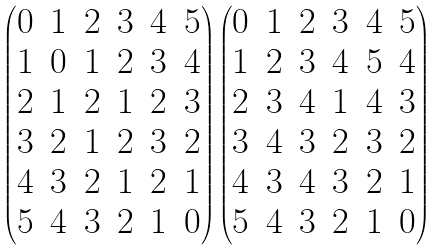<formula> <loc_0><loc_0><loc_500><loc_500>\begin{pmatrix} 0 & 1 & 2 & 3 & 4 & 5 \\ 1 & 0 & 1 & 2 & 3 & 4 \\ 2 & 1 & 2 & 1 & 2 & 3 \\ 3 & 2 & 1 & 2 & 3 & 2 \\ 4 & 3 & 2 & 1 & 2 & 1 \\ 5 & 4 & 3 & 2 & 1 & 0 \end{pmatrix} \begin{pmatrix} 0 & 1 & 2 & 3 & 4 & 5 \\ 1 & 2 & 3 & 4 & 5 & 4 \\ 2 & 3 & 4 & 1 & 4 & 3 \\ 3 & 4 & 3 & 2 & 3 & 2 \\ 4 & 3 & 4 & 3 & 2 & 1 \\ 5 & 4 & 3 & 2 & 1 & 0 \end{pmatrix}</formula> 